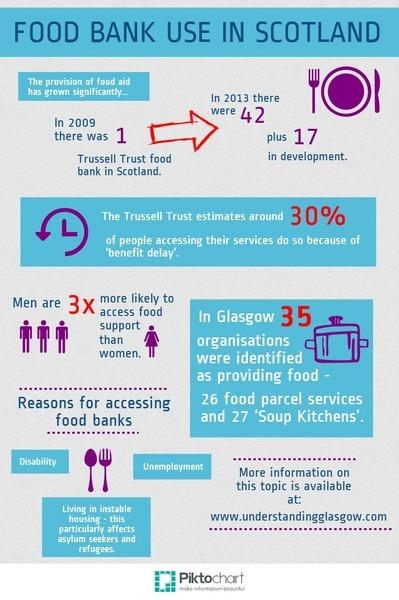Point out several critical features in this image. The infographic shows 1 image of a woman. The necessity for depending on food banks is demonstrated by the listing of three reasons to show the importance of relying on them. The second reason listed to demonstrate the importance of relying on food banks is unemployment. 